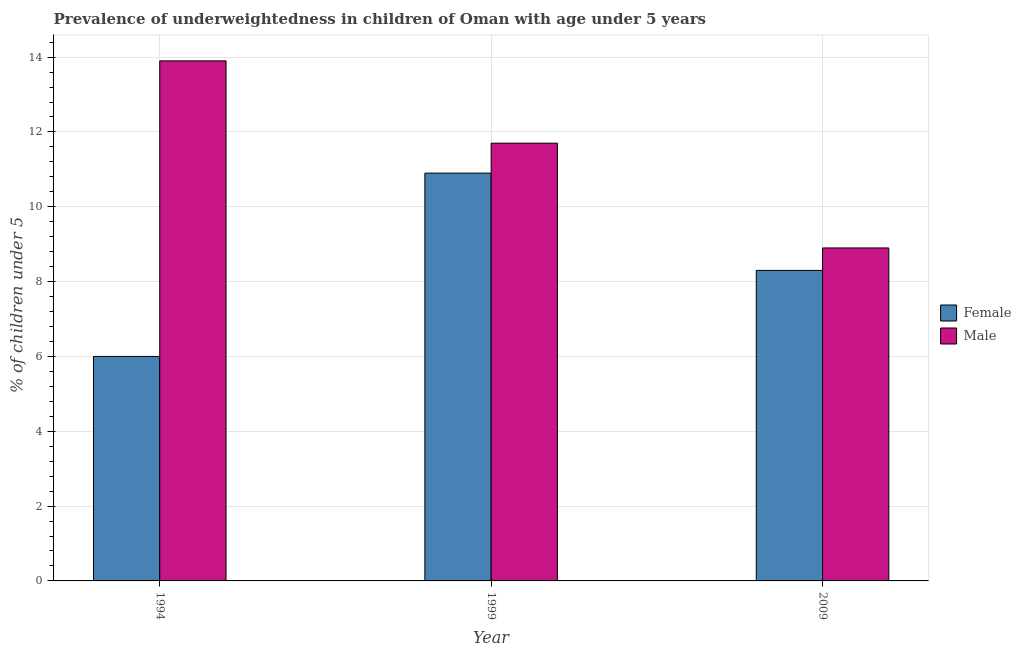How many different coloured bars are there?
Give a very brief answer. 2. How many groups of bars are there?
Your answer should be compact. 3. How many bars are there on the 2nd tick from the left?
Offer a very short reply. 2. What is the percentage of underweighted female children in 2009?
Ensure brevity in your answer.  8.3. Across all years, what is the maximum percentage of underweighted male children?
Your answer should be very brief. 13.9. Across all years, what is the minimum percentage of underweighted male children?
Keep it short and to the point. 8.9. What is the total percentage of underweighted female children in the graph?
Offer a very short reply. 25.2. What is the difference between the percentage of underweighted female children in 1994 and that in 2009?
Ensure brevity in your answer.  -2.3. What is the difference between the percentage of underweighted female children in 1994 and the percentage of underweighted male children in 2009?
Provide a succinct answer. -2.3. What is the average percentage of underweighted female children per year?
Your response must be concise. 8.4. In how many years, is the percentage of underweighted female children greater than 7.6 %?
Provide a short and direct response. 2. What is the ratio of the percentage of underweighted female children in 1999 to that in 2009?
Offer a terse response. 1.31. What is the difference between the highest and the second highest percentage of underweighted male children?
Offer a terse response. 2.2. What is the difference between the highest and the lowest percentage of underweighted female children?
Keep it short and to the point. 4.9. What does the 1st bar from the left in 1994 represents?
Offer a very short reply. Female. What does the 1st bar from the right in 1999 represents?
Your answer should be very brief. Male. How many bars are there?
Provide a short and direct response. 6. How many years are there in the graph?
Your answer should be very brief. 3. What is the difference between two consecutive major ticks on the Y-axis?
Offer a very short reply. 2. Are the values on the major ticks of Y-axis written in scientific E-notation?
Offer a terse response. No. Does the graph contain any zero values?
Offer a very short reply. No. How are the legend labels stacked?
Offer a very short reply. Vertical. What is the title of the graph?
Keep it short and to the point. Prevalence of underweightedness in children of Oman with age under 5 years. Does "Stunting" appear as one of the legend labels in the graph?
Offer a terse response. No. What is the label or title of the Y-axis?
Make the answer very short.  % of children under 5. What is the  % of children under 5 in Male in 1994?
Keep it short and to the point. 13.9. What is the  % of children under 5 of Female in 1999?
Give a very brief answer. 10.9. What is the  % of children under 5 of Male in 1999?
Give a very brief answer. 11.7. What is the  % of children under 5 in Female in 2009?
Give a very brief answer. 8.3. What is the  % of children under 5 of Male in 2009?
Offer a terse response. 8.9. Across all years, what is the maximum  % of children under 5 of Female?
Your response must be concise. 10.9. Across all years, what is the maximum  % of children under 5 of Male?
Ensure brevity in your answer.  13.9. Across all years, what is the minimum  % of children under 5 in Female?
Offer a terse response. 6. Across all years, what is the minimum  % of children under 5 of Male?
Offer a terse response. 8.9. What is the total  % of children under 5 of Female in the graph?
Your response must be concise. 25.2. What is the total  % of children under 5 in Male in the graph?
Your answer should be very brief. 34.5. What is the difference between the  % of children under 5 in Male in 1994 and that in 2009?
Give a very brief answer. 5. What is the difference between the  % of children under 5 in Male in 1999 and that in 2009?
Make the answer very short. 2.8. What is the difference between the  % of children under 5 of Female in 1994 and the  % of children under 5 of Male in 2009?
Keep it short and to the point. -2.9. What is the difference between the  % of children under 5 in Female in 1999 and the  % of children under 5 in Male in 2009?
Ensure brevity in your answer.  2. What is the average  % of children under 5 in Male per year?
Give a very brief answer. 11.5. In the year 1999, what is the difference between the  % of children under 5 in Female and  % of children under 5 in Male?
Ensure brevity in your answer.  -0.8. In the year 2009, what is the difference between the  % of children under 5 in Female and  % of children under 5 in Male?
Ensure brevity in your answer.  -0.6. What is the ratio of the  % of children under 5 in Female in 1994 to that in 1999?
Your response must be concise. 0.55. What is the ratio of the  % of children under 5 of Male in 1994 to that in 1999?
Provide a short and direct response. 1.19. What is the ratio of the  % of children under 5 of Female in 1994 to that in 2009?
Make the answer very short. 0.72. What is the ratio of the  % of children under 5 of Male in 1994 to that in 2009?
Provide a short and direct response. 1.56. What is the ratio of the  % of children under 5 of Female in 1999 to that in 2009?
Your response must be concise. 1.31. What is the ratio of the  % of children under 5 in Male in 1999 to that in 2009?
Provide a succinct answer. 1.31. What is the difference between the highest and the second highest  % of children under 5 of Male?
Offer a very short reply. 2.2. What is the difference between the highest and the lowest  % of children under 5 of Female?
Offer a very short reply. 4.9. What is the difference between the highest and the lowest  % of children under 5 in Male?
Your response must be concise. 5. 